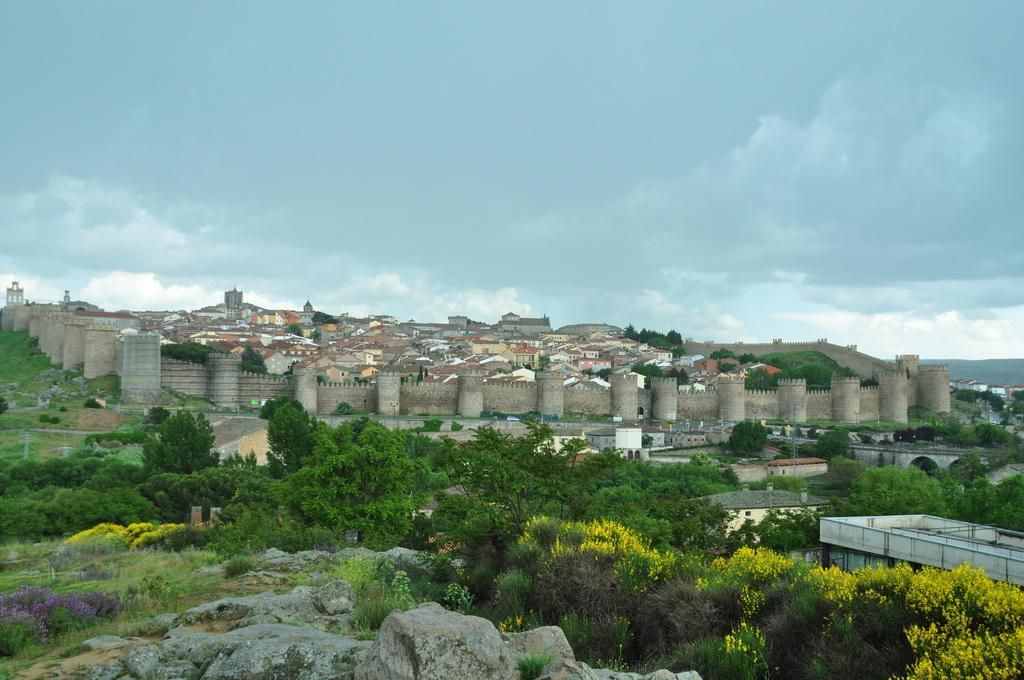What type of natural elements can be seen in the image? There are trees in the image. What type of objects can be seen in the image? There are stones and buildings in the image. What is visible in the background of the image? There is a boundary in the background of the image. What is the condition of the sky in the image? The sky is cloudy in the image. Can you tell me how many clams are visible on the stones in the image? There are no clams present in the image; it features trees, stones, buildings, and a boundary. What type of quiver is being used by the trees in the image? There is no quiver present in the image, as trees do not use quivers. 